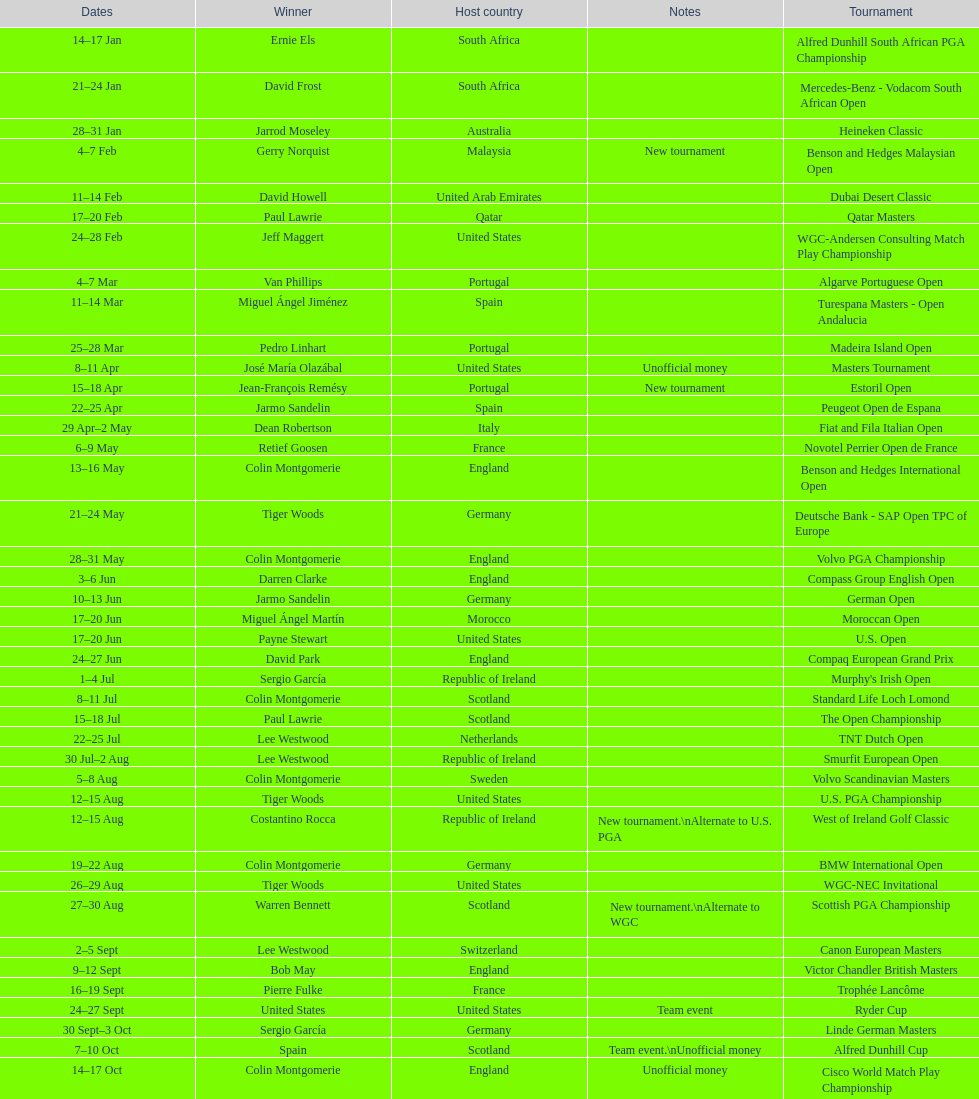How many tournaments began before aug 15th 31. 